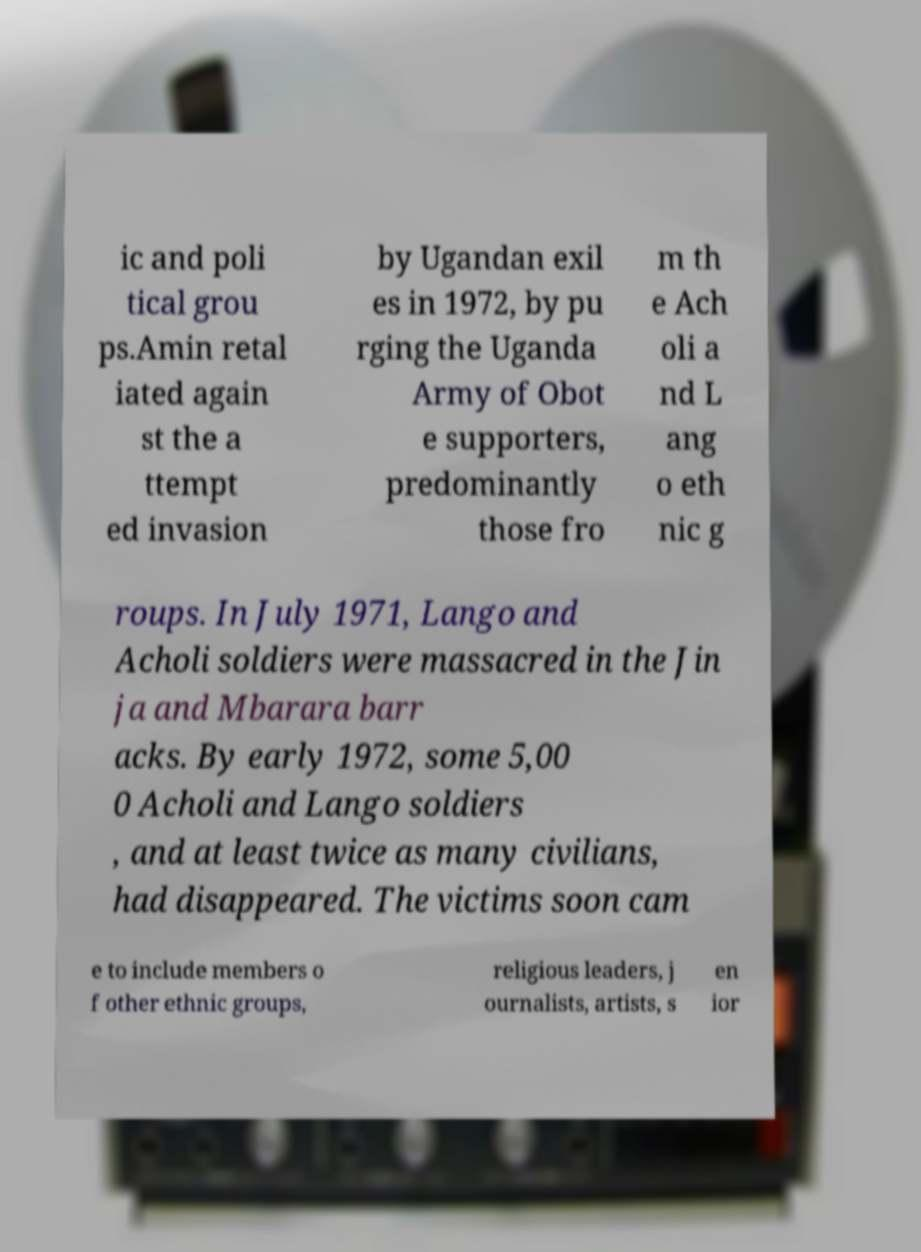Can you accurately transcribe the text from the provided image for me? ic and poli tical grou ps.Amin retal iated again st the a ttempt ed invasion by Ugandan exil es in 1972, by pu rging the Uganda Army of Obot e supporters, predominantly those fro m th e Ach oli a nd L ang o eth nic g roups. In July 1971, Lango and Acholi soldiers were massacred in the Jin ja and Mbarara barr acks. By early 1972, some 5,00 0 Acholi and Lango soldiers , and at least twice as many civilians, had disappeared. The victims soon cam e to include members o f other ethnic groups, religious leaders, j ournalists, artists, s en ior 